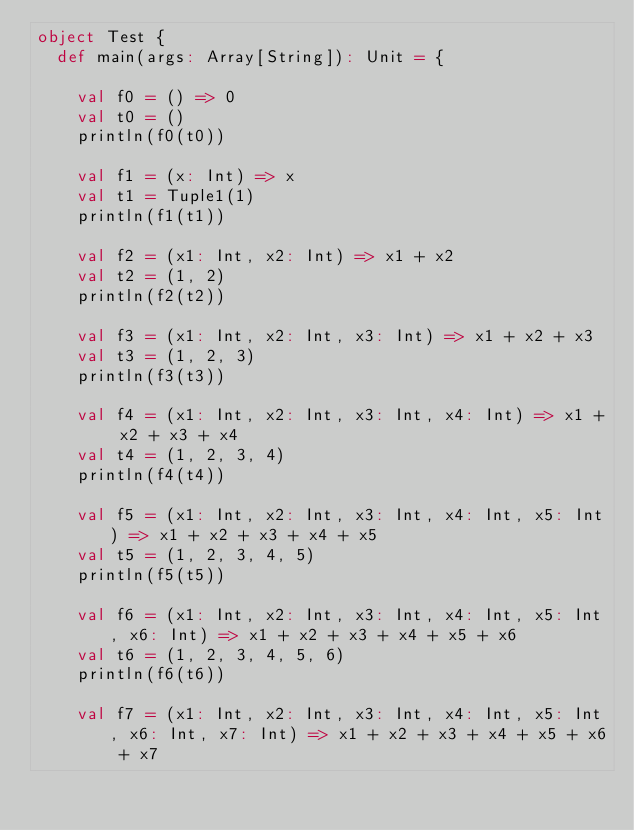Convert code to text. <code><loc_0><loc_0><loc_500><loc_500><_Scala_>object Test {
  def main(args: Array[String]): Unit = {

    val f0 = () => 0
    val t0 = ()
    println(f0(t0))

    val f1 = (x: Int) => x
    val t1 = Tuple1(1)
    println(f1(t1))

    val f2 = (x1: Int, x2: Int) => x1 + x2
    val t2 = (1, 2)
    println(f2(t2))

    val f3 = (x1: Int, x2: Int, x3: Int) => x1 + x2 + x3
    val t3 = (1, 2, 3)
    println(f3(t3))

    val f4 = (x1: Int, x2: Int, x3: Int, x4: Int) => x1 + x2 + x3 + x4
    val t4 = (1, 2, 3, 4)
    println(f4(t4))

    val f5 = (x1: Int, x2: Int, x3: Int, x4: Int, x5: Int) => x1 + x2 + x3 + x4 + x5
    val t5 = (1, 2, 3, 4, 5)
    println(f5(t5))

    val f6 = (x1: Int, x2: Int, x3: Int, x4: Int, x5: Int, x6: Int) => x1 + x2 + x3 + x4 + x5 + x6
    val t6 = (1, 2, 3, 4, 5, 6)
    println(f6(t6))

    val f7 = (x1: Int, x2: Int, x3: Int, x4: Int, x5: Int, x6: Int, x7: Int) => x1 + x2 + x3 + x4 + x5 + x6 + x7</code> 